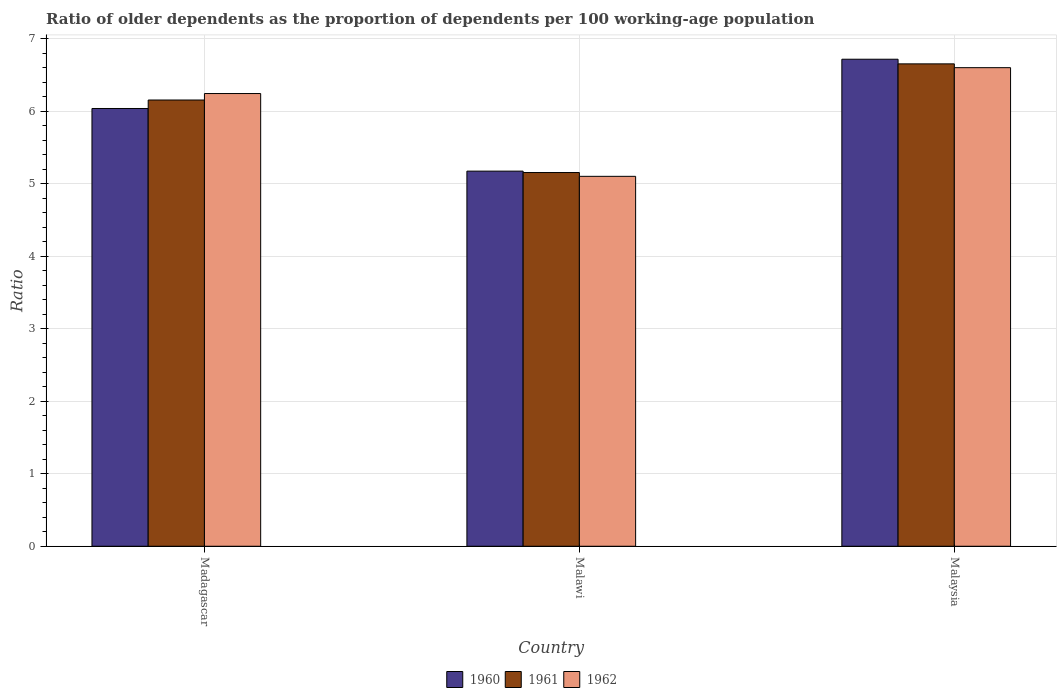How many different coloured bars are there?
Provide a short and direct response. 3. How many groups of bars are there?
Provide a succinct answer. 3. How many bars are there on the 3rd tick from the left?
Your answer should be very brief. 3. How many bars are there on the 3rd tick from the right?
Keep it short and to the point. 3. What is the label of the 3rd group of bars from the left?
Your answer should be compact. Malaysia. What is the age dependency ratio(old) in 1960 in Malawi?
Your answer should be compact. 5.17. Across all countries, what is the maximum age dependency ratio(old) in 1960?
Provide a short and direct response. 6.71. Across all countries, what is the minimum age dependency ratio(old) in 1960?
Give a very brief answer. 5.17. In which country was the age dependency ratio(old) in 1961 maximum?
Your answer should be very brief. Malaysia. In which country was the age dependency ratio(old) in 1962 minimum?
Make the answer very short. Malawi. What is the total age dependency ratio(old) in 1961 in the graph?
Make the answer very short. 17.96. What is the difference between the age dependency ratio(old) in 1961 in Madagascar and that in Malawi?
Offer a very short reply. 1. What is the difference between the age dependency ratio(old) in 1960 in Madagascar and the age dependency ratio(old) in 1962 in Malawi?
Make the answer very short. 0.94. What is the average age dependency ratio(old) in 1960 per country?
Give a very brief answer. 5.97. What is the difference between the age dependency ratio(old) of/in 1960 and age dependency ratio(old) of/in 1961 in Malawi?
Provide a short and direct response. 0.02. What is the ratio of the age dependency ratio(old) in 1961 in Malawi to that in Malaysia?
Make the answer very short. 0.77. Is the difference between the age dependency ratio(old) in 1960 in Malawi and Malaysia greater than the difference between the age dependency ratio(old) in 1961 in Malawi and Malaysia?
Give a very brief answer. No. What is the difference between the highest and the second highest age dependency ratio(old) in 1962?
Give a very brief answer. -1.5. What is the difference between the highest and the lowest age dependency ratio(old) in 1962?
Offer a very short reply. 1.5. In how many countries, is the age dependency ratio(old) in 1961 greater than the average age dependency ratio(old) in 1961 taken over all countries?
Provide a succinct answer. 2. Is the sum of the age dependency ratio(old) in 1960 in Madagascar and Malawi greater than the maximum age dependency ratio(old) in 1961 across all countries?
Offer a terse response. Yes. What does the 1st bar from the left in Malawi represents?
Your answer should be very brief. 1960. Is it the case that in every country, the sum of the age dependency ratio(old) in 1962 and age dependency ratio(old) in 1960 is greater than the age dependency ratio(old) in 1961?
Your answer should be compact. Yes. How many bars are there?
Ensure brevity in your answer.  9. How many countries are there in the graph?
Offer a terse response. 3. Are the values on the major ticks of Y-axis written in scientific E-notation?
Keep it short and to the point. No. Does the graph contain any zero values?
Your answer should be very brief. No. How many legend labels are there?
Make the answer very short. 3. How are the legend labels stacked?
Your answer should be very brief. Horizontal. What is the title of the graph?
Your answer should be very brief. Ratio of older dependents as the proportion of dependents per 100 working-age population. What is the label or title of the Y-axis?
Offer a very short reply. Ratio. What is the Ratio of 1960 in Madagascar?
Make the answer very short. 6.04. What is the Ratio of 1961 in Madagascar?
Your response must be concise. 6.15. What is the Ratio of 1962 in Madagascar?
Provide a short and direct response. 6.24. What is the Ratio in 1960 in Malawi?
Your answer should be very brief. 5.17. What is the Ratio of 1961 in Malawi?
Ensure brevity in your answer.  5.15. What is the Ratio in 1962 in Malawi?
Your answer should be very brief. 5.1. What is the Ratio of 1960 in Malaysia?
Provide a short and direct response. 6.71. What is the Ratio of 1961 in Malaysia?
Provide a succinct answer. 6.65. What is the Ratio in 1962 in Malaysia?
Make the answer very short. 6.6. Across all countries, what is the maximum Ratio of 1960?
Ensure brevity in your answer.  6.71. Across all countries, what is the maximum Ratio in 1961?
Provide a short and direct response. 6.65. Across all countries, what is the maximum Ratio in 1962?
Keep it short and to the point. 6.6. Across all countries, what is the minimum Ratio in 1960?
Your response must be concise. 5.17. Across all countries, what is the minimum Ratio of 1961?
Provide a succinct answer. 5.15. Across all countries, what is the minimum Ratio in 1962?
Your answer should be very brief. 5.1. What is the total Ratio in 1960 in the graph?
Keep it short and to the point. 17.92. What is the total Ratio in 1961 in the graph?
Ensure brevity in your answer.  17.96. What is the total Ratio in 1962 in the graph?
Your response must be concise. 17.94. What is the difference between the Ratio in 1960 in Madagascar and that in Malawi?
Make the answer very short. 0.86. What is the difference between the Ratio of 1962 in Madagascar and that in Malawi?
Make the answer very short. 1.14. What is the difference between the Ratio in 1960 in Madagascar and that in Malaysia?
Give a very brief answer. -0.68. What is the difference between the Ratio in 1961 in Madagascar and that in Malaysia?
Keep it short and to the point. -0.5. What is the difference between the Ratio of 1962 in Madagascar and that in Malaysia?
Your answer should be very brief. -0.36. What is the difference between the Ratio of 1960 in Malawi and that in Malaysia?
Give a very brief answer. -1.54. What is the difference between the Ratio of 1961 in Malawi and that in Malaysia?
Your answer should be compact. -1.5. What is the difference between the Ratio in 1962 in Malawi and that in Malaysia?
Give a very brief answer. -1.5. What is the difference between the Ratio of 1960 in Madagascar and the Ratio of 1961 in Malawi?
Ensure brevity in your answer.  0.88. What is the difference between the Ratio of 1960 in Madagascar and the Ratio of 1962 in Malawi?
Make the answer very short. 0.94. What is the difference between the Ratio of 1961 in Madagascar and the Ratio of 1962 in Malawi?
Make the answer very short. 1.05. What is the difference between the Ratio of 1960 in Madagascar and the Ratio of 1961 in Malaysia?
Your answer should be very brief. -0.62. What is the difference between the Ratio of 1960 in Madagascar and the Ratio of 1962 in Malaysia?
Provide a short and direct response. -0.56. What is the difference between the Ratio of 1961 in Madagascar and the Ratio of 1962 in Malaysia?
Your answer should be compact. -0.45. What is the difference between the Ratio of 1960 in Malawi and the Ratio of 1961 in Malaysia?
Ensure brevity in your answer.  -1.48. What is the difference between the Ratio in 1960 in Malawi and the Ratio in 1962 in Malaysia?
Your answer should be compact. -1.43. What is the difference between the Ratio of 1961 in Malawi and the Ratio of 1962 in Malaysia?
Ensure brevity in your answer.  -1.45. What is the average Ratio in 1960 per country?
Provide a short and direct response. 5.97. What is the average Ratio in 1961 per country?
Offer a terse response. 5.99. What is the average Ratio in 1962 per country?
Offer a very short reply. 5.98. What is the difference between the Ratio of 1960 and Ratio of 1961 in Madagascar?
Offer a very short reply. -0.12. What is the difference between the Ratio of 1960 and Ratio of 1962 in Madagascar?
Provide a short and direct response. -0.21. What is the difference between the Ratio of 1961 and Ratio of 1962 in Madagascar?
Offer a very short reply. -0.09. What is the difference between the Ratio of 1960 and Ratio of 1961 in Malawi?
Keep it short and to the point. 0.02. What is the difference between the Ratio in 1960 and Ratio in 1962 in Malawi?
Provide a short and direct response. 0.07. What is the difference between the Ratio in 1961 and Ratio in 1962 in Malawi?
Provide a succinct answer. 0.05. What is the difference between the Ratio in 1960 and Ratio in 1961 in Malaysia?
Provide a succinct answer. 0.06. What is the difference between the Ratio of 1960 and Ratio of 1962 in Malaysia?
Provide a succinct answer. 0.12. What is the difference between the Ratio in 1961 and Ratio in 1962 in Malaysia?
Offer a terse response. 0.05. What is the ratio of the Ratio in 1960 in Madagascar to that in Malawi?
Your answer should be compact. 1.17. What is the ratio of the Ratio in 1961 in Madagascar to that in Malawi?
Your answer should be compact. 1.19. What is the ratio of the Ratio in 1962 in Madagascar to that in Malawi?
Your response must be concise. 1.22. What is the ratio of the Ratio in 1960 in Madagascar to that in Malaysia?
Your answer should be very brief. 0.9. What is the ratio of the Ratio of 1961 in Madagascar to that in Malaysia?
Give a very brief answer. 0.93. What is the ratio of the Ratio of 1962 in Madagascar to that in Malaysia?
Offer a very short reply. 0.95. What is the ratio of the Ratio of 1960 in Malawi to that in Malaysia?
Keep it short and to the point. 0.77. What is the ratio of the Ratio in 1961 in Malawi to that in Malaysia?
Your response must be concise. 0.77. What is the ratio of the Ratio in 1962 in Malawi to that in Malaysia?
Ensure brevity in your answer.  0.77. What is the difference between the highest and the second highest Ratio of 1960?
Ensure brevity in your answer.  0.68. What is the difference between the highest and the second highest Ratio of 1961?
Your answer should be compact. 0.5. What is the difference between the highest and the second highest Ratio of 1962?
Provide a short and direct response. 0.36. What is the difference between the highest and the lowest Ratio of 1960?
Give a very brief answer. 1.54. What is the difference between the highest and the lowest Ratio in 1961?
Make the answer very short. 1.5. What is the difference between the highest and the lowest Ratio of 1962?
Offer a very short reply. 1.5. 